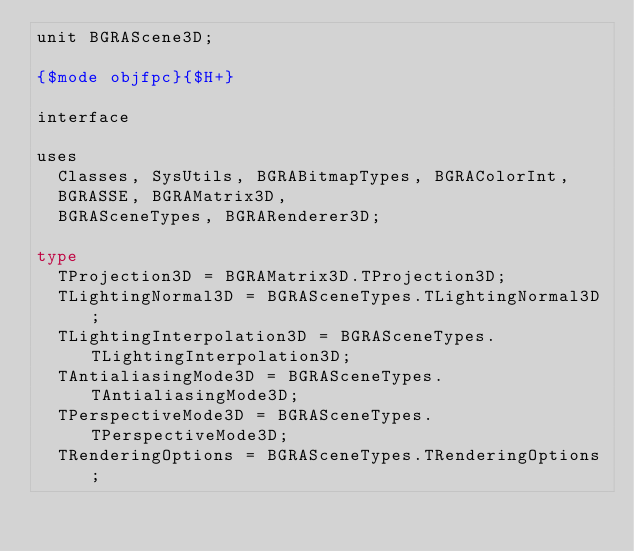Convert code to text. <code><loc_0><loc_0><loc_500><loc_500><_Pascal_>unit BGRAScene3D;

{$mode objfpc}{$H+}

interface

uses
  Classes, SysUtils, BGRABitmapTypes, BGRAColorInt,
  BGRASSE, BGRAMatrix3D,
  BGRASceneTypes, BGRARenderer3D;

type
  TProjection3D = BGRAMatrix3D.TProjection3D;
  TLightingNormal3D = BGRASceneTypes.TLightingNormal3D;
  TLightingInterpolation3D = BGRASceneTypes.TLightingInterpolation3D;
  TAntialiasingMode3D = BGRASceneTypes.TAntialiasingMode3D;
  TPerspectiveMode3D = BGRASceneTypes.TPerspectiveMode3D;
  TRenderingOptions = BGRASceneTypes.TRenderingOptions;
</code> 